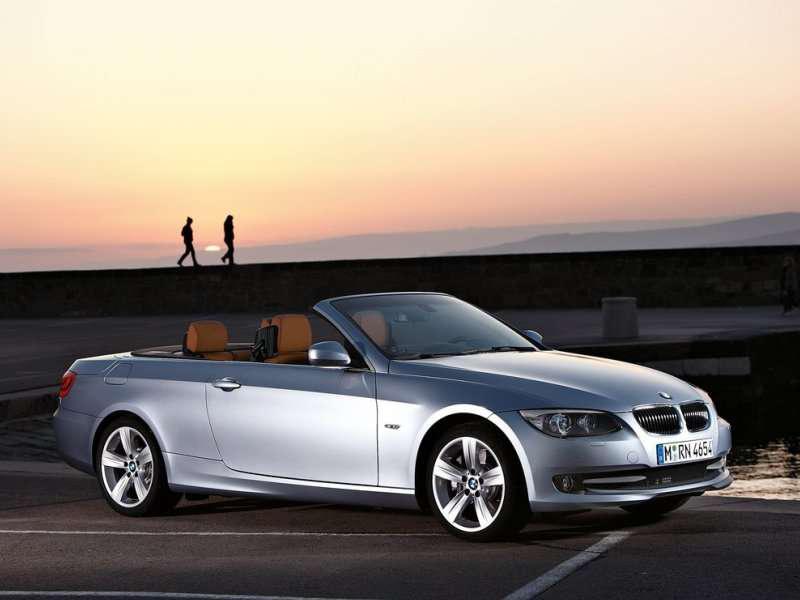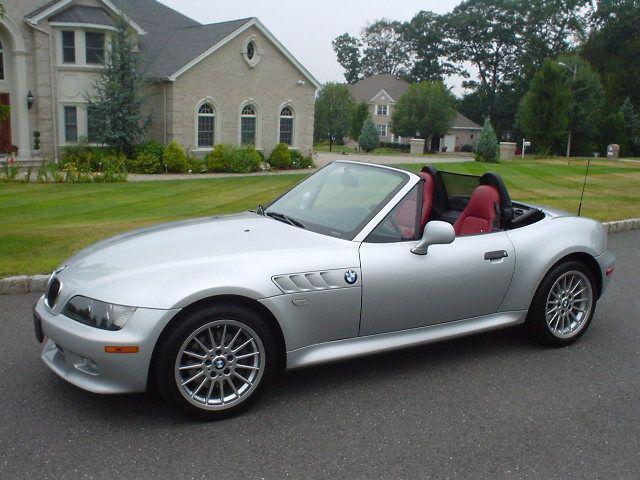The first image is the image on the left, the second image is the image on the right. Assess this claim about the two images: "There is 1 or more silver cars on the road.". Correct or not? Answer yes or no. Yes. The first image is the image on the left, the second image is the image on the right. Considering the images on both sides, is "there is a car parked on the street in front of a house" valid? Answer yes or no. Yes. 